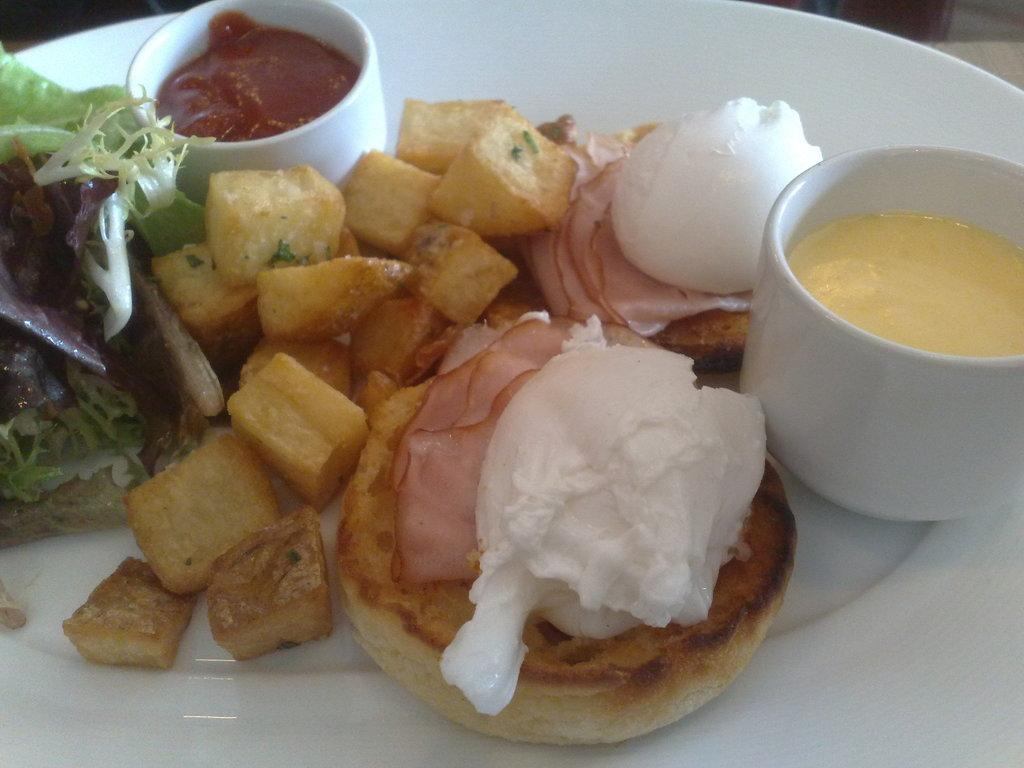What is present on the plate in the image? There is a plate in the image, and it contains two bowls and other food items. What are the bowls holding? The bowls contain creams. Can you describe the other food items on the plate? Unfortunately, the facts provided do not specify the other food items on the plate. What type of roof can be seen on the plate in the image? There is no roof present in the image; it features a plate with two bowls and other food items. How many wounds are visible on the plate in the image? There are no wounds visible on the plate in the image; it features a plate with two bowls and other food items. 